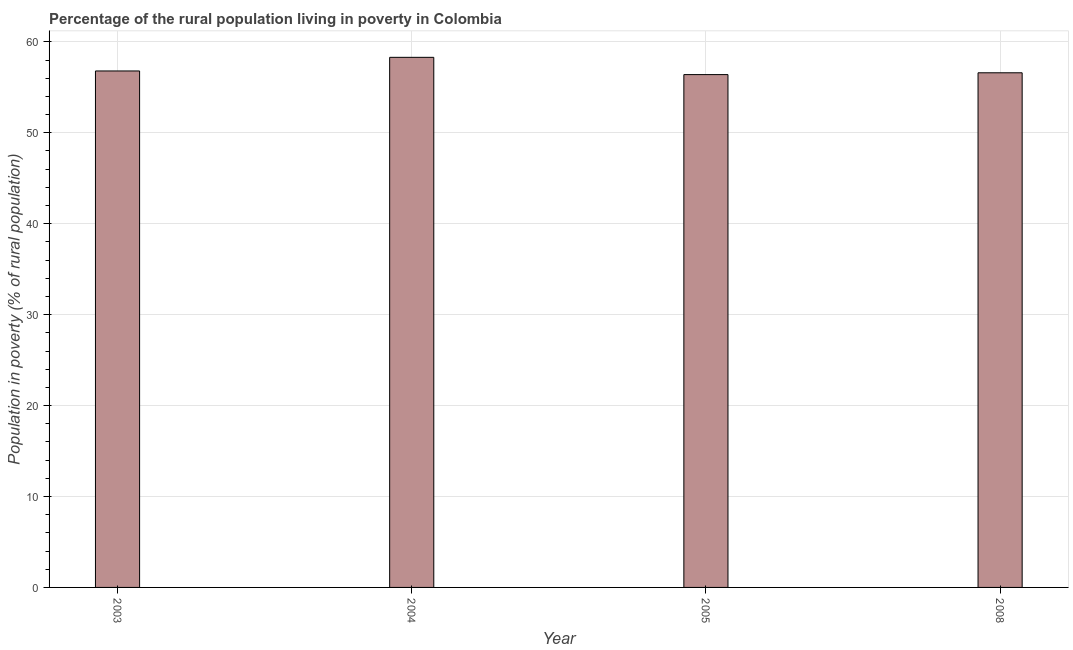Does the graph contain any zero values?
Your answer should be very brief. No. Does the graph contain grids?
Ensure brevity in your answer.  Yes. What is the title of the graph?
Provide a short and direct response. Percentage of the rural population living in poverty in Colombia. What is the label or title of the X-axis?
Your answer should be very brief. Year. What is the label or title of the Y-axis?
Offer a very short reply. Population in poverty (% of rural population). What is the percentage of rural population living below poverty line in 2005?
Keep it short and to the point. 56.4. Across all years, what is the maximum percentage of rural population living below poverty line?
Provide a short and direct response. 58.3. Across all years, what is the minimum percentage of rural population living below poverty line?
Give a very brief answer. 56.4. In which year was the percentage of rural population living below poverty line maximum?
Provide a short and direct response. 2004. What is the sum of the percentage of rural population living below poverty line?
Offer a terse response. 228.1. What is the difference between the percentage of rural population living below poverty line in 2003 and 2008?
Your response must be concise. 0.2. What is the average percentage of rural population living below poverty line per year?
Your answer should be compact. 57.02. What is the median percentage of rural population living below poverty line?
Make the answer very short. 56.7. In how many years, is the percentage of rural population living below poverty line greater than 18 %?
Your response must be concise. 4. Do a majority of the years between 2003 and 2008 (inclusive) have percentage of rural population living below poverty line greater than 58 %?
Offer a very short reply. No. What is the ratio of the percentage of rural population living below poverty line in 2004 to that in 2005?
Keep it short and to the point. 1.03. Is the percentage of rural population living below poverty line in 2003 less than that in 2005?
Keep it short and to the point. No. What is the difference between the highest and the second highest percentage of rural population living below poverty line?
Provide a short and direct response. 1.5. What is the difference between the highest and the lowest percentage of rural population living below poverty line?
Make the answer very short. 1.9. Are all the bars in the graph horizontal?
Keep it short and to the point. No. What is the Population in poverty (% of rural population) of 2003?
Provide a short and direct response. 56.8. What is the Population in poverty (% of rural population) of 2004?
Provide a short and direct response. 58.3. What is the Population in poverty (% of rural population) in 2005?
Your answer should be compact. 56.4. What is the Population in poverty (% of rural population) in 2008?
Provide a short and direct response. 56.6. What is the difference between the Population in poverty (% of rural population) in 2005 and 2008?
Your response must be concise. -0.2. What is the ratio of the Population in poverty (% of rural population) in 2003 to that in 2004?
Ensure brevity in your answer.  0.97. What is the ratio of the Population in poverty (% of rural population) in 2003 to that in 2008?
Provide a succinct answer. 1. What is the ratio of the Population in poverty (% of rural population) in 2004 to that in 2005?
Make the answer very short. 1.03. What is the ratio of the Population in poverty (% of rural population) in 2005 to that in 2008?
Your answer should be very brief. 1. 